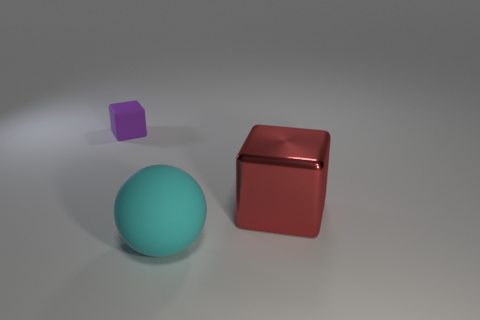What number of purple objects have the same shape as the large red metal object?
Offer a terse response. 1. Is the material of the purple object the same as the big thing that is to the left of the large cube?
Offer a very short reply. Yes. The other object that is the same material as the cyan object is what size?
Keep it short and to the point. Small. There is a rubber thing that is in front of the big red thing; what size is it?
Provide a succinct answer. Large. What number of cyan balls have the same size as the shiny cube?
Offer a very short reply. 1. Is there a tiny rubber object of the same color as the small matte block?
Provide a succinct answer. No. There is a matte object that is the same size as the shiny cube; what is its color?
Offer a terse response. Cyan. There is a large metal thing; does it have the same color as the matte thing that is behind the cyan matte thing?
Give a very brief answer. No. What color is the big matte ball?
Your answer should be compact. Cyan. What material is the large thing that is to the right of the ball?
Your response must be concise. Metal. 